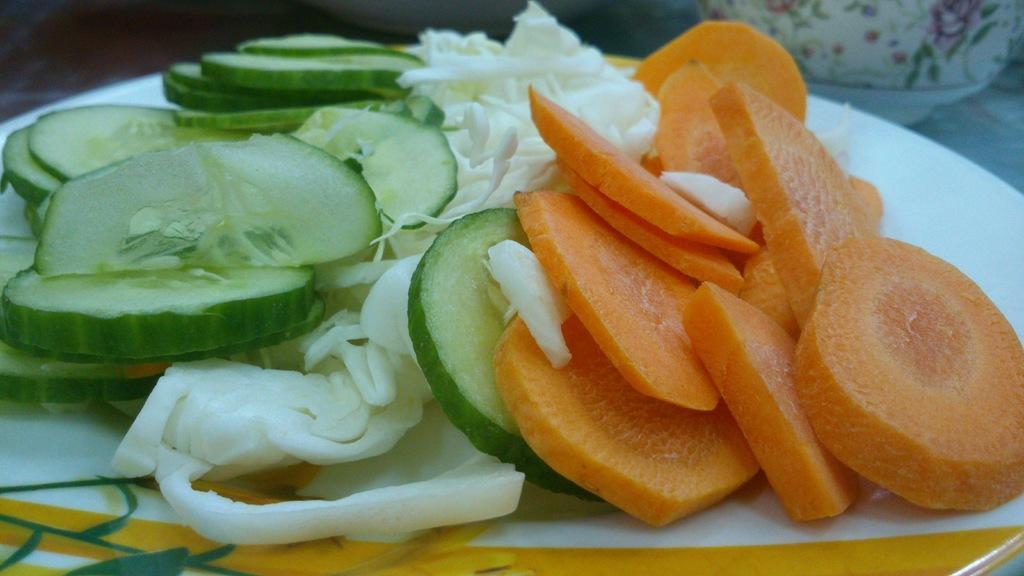In one or two sentences, can you explain what this image depicts? In this picture, we see a white plate containing the chopped carrots, cabbage and cucumbers. In the right bottom, we see a cup. 